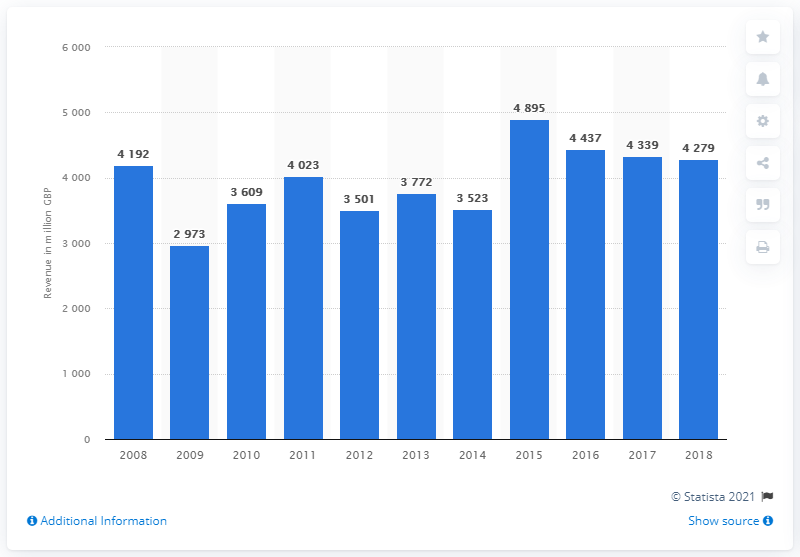Draw attention to some important aspects in this diagram. The turnover from the retail sale of plants and flowers in 2009 was 2973. The turnover from the retail sale of plants and flowers in 2008 was 4192. 